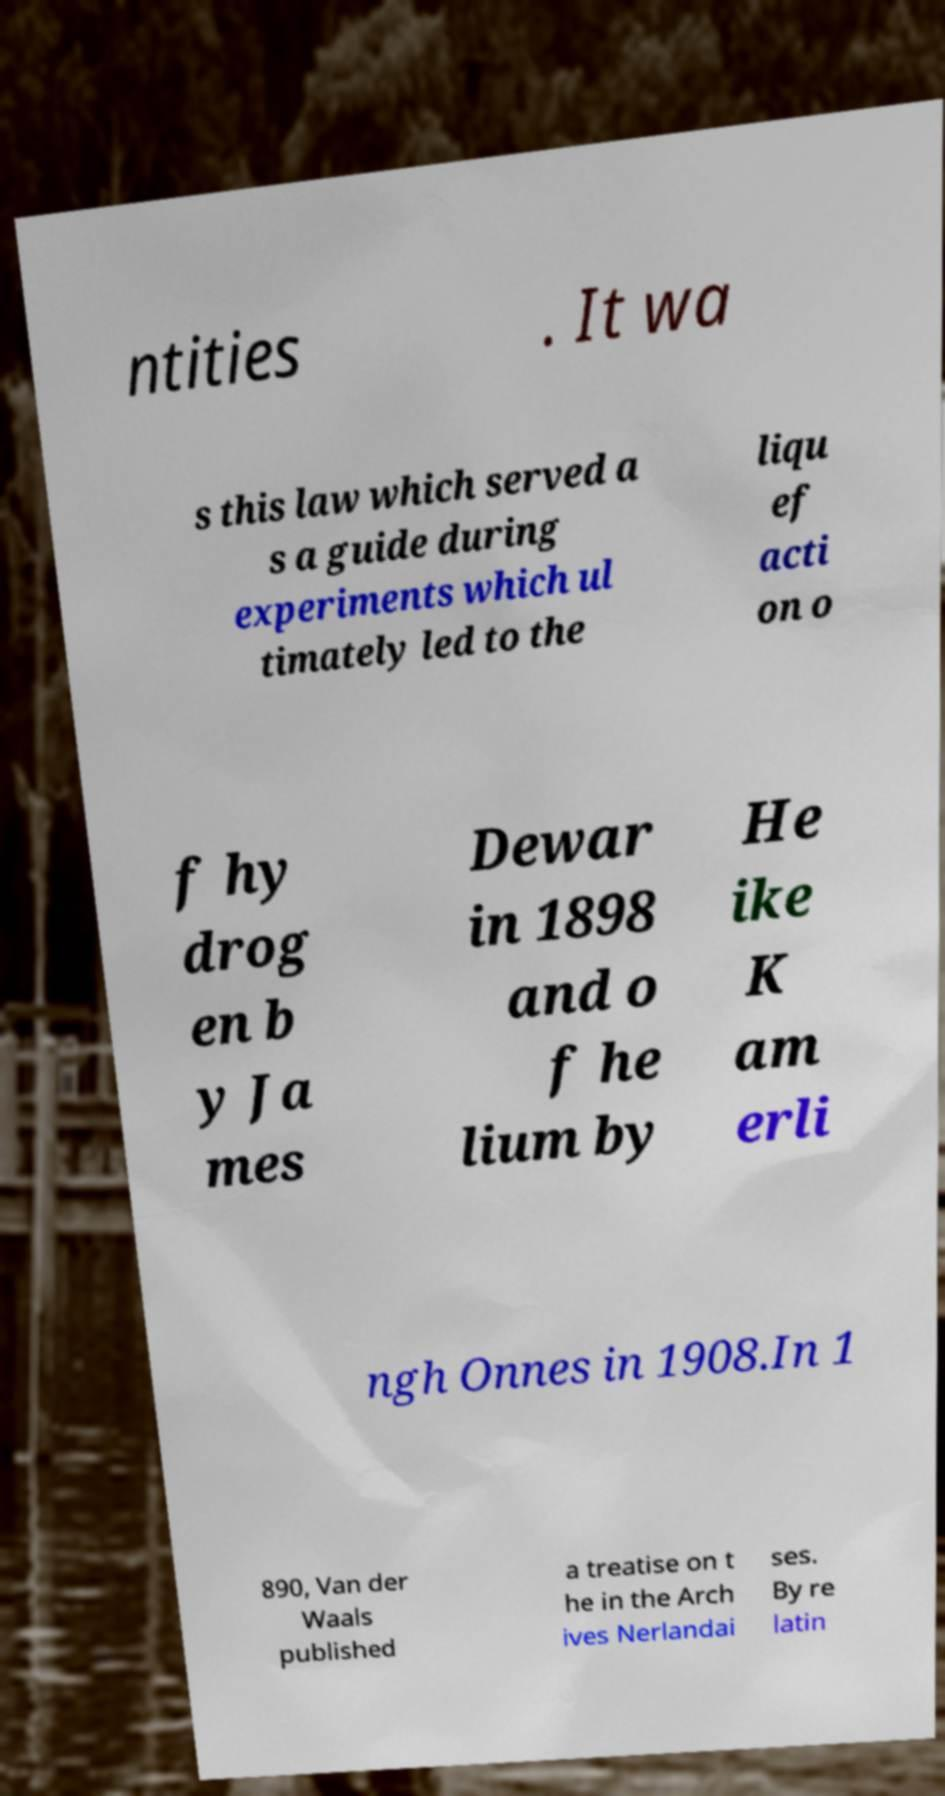Can you read and provide the text displayed in the image?This photo seems to have some interesting text. Can you extract and type it out for me? ntities . It wa s this law which served a s a guide during experiments which ul timately led to the liqu ef acti on o f hy drog en b y Ja mes Dewar in 1898 and o f he lium by He ike K am erli ngh Onnes in 1908.In 1 890, Van der Waals published a treatise on t he in the Arch ives Nerlandai ses. By re latin 